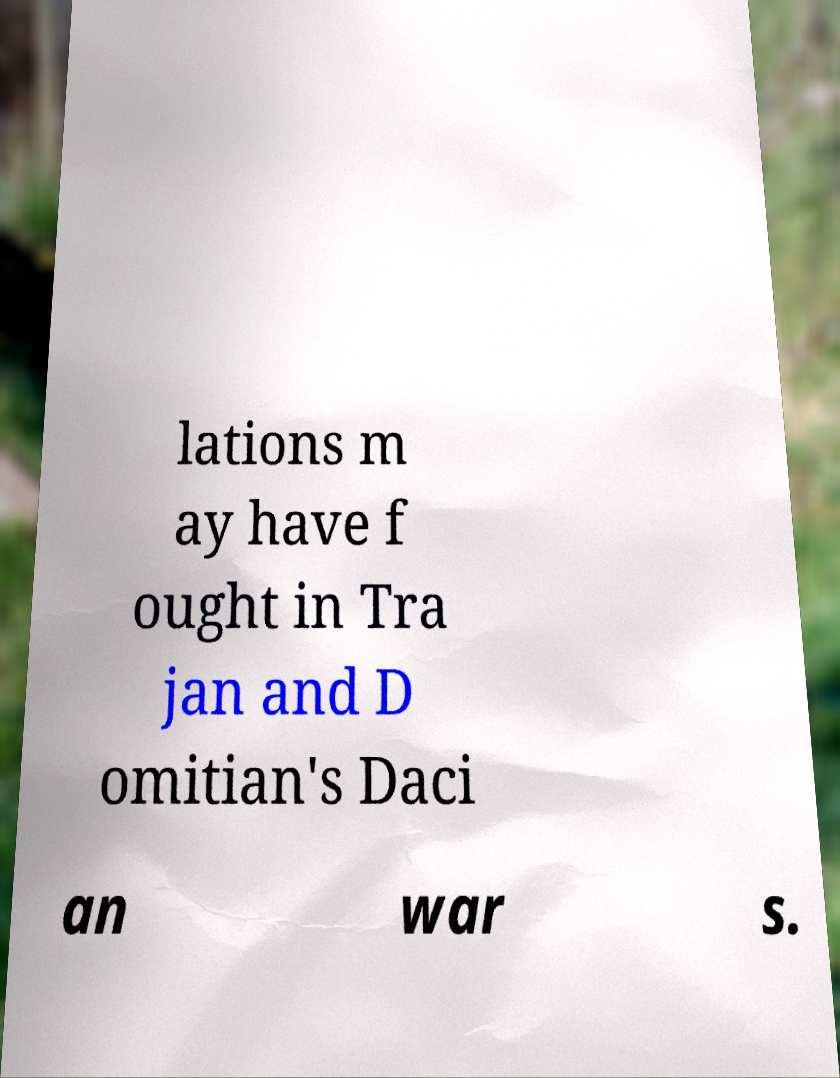For documentation purposes, I need the text within this image transcribed. Could you provide that? lations m ay have f ought in Tra jan and D omitian's Daci an war s. 